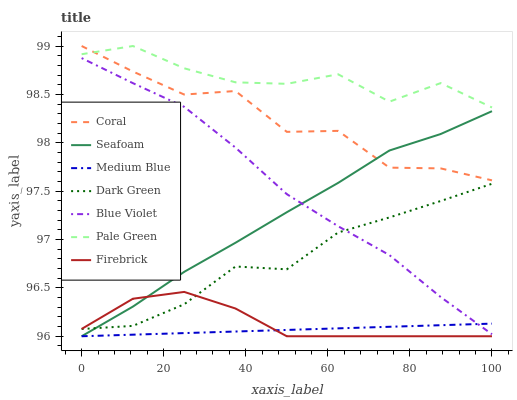Does Medium Blue have the minimum area under the curve?
Answer yes or no. Yes. Does Pale Green have the maximum area under the curve?
Answer yes or no. Yes. Does Seafoam have the minimum area under the curve?
Answer yes or no. No. Does Seafoam have the maximum area under the curve?
Answer yes or no. No. Is Medium Blue the smoothest?
Answer yes or no. Yes. Is Coral the roughest?
Answer yes or no. Yes. Is Seafoam the smoothest?
Answer yes or no. No. Is Seafoam the roughest?
Answer yes or no. No. Does Medium Blue have the lowest value?
Answer yes or no. Yes. Does Pale Green have the lowest value?
Answer yes or no. No. Does Pale Green have the highest value?
Answer yes or no. Yes. Does Seafoam have the highest value?
Answer yes or no. No. Is Firebrick less than Pale Green?
Answer yes or no. Yes. Is Coral greater than Medium Blue?
Answer yes or no. Yes. Does Medium Blue intersect Seafoam?
Answer yes or no. Yes. Is Medium Blue less than Seafoam?
Answer yes or no. No. Is Medium Blue greater than Seafoam?
Answer yes or no. No. Does Firebrick intersect Pale Green?
Answer yes or no. No. 